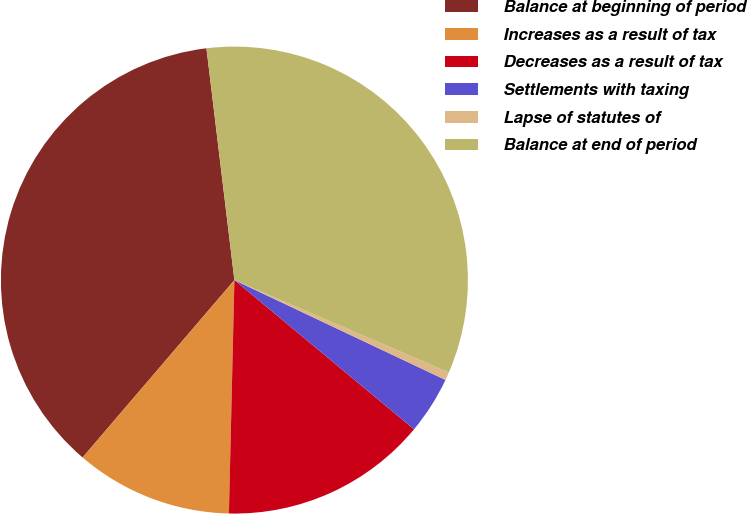Convert chart. <chart><loc_0><loc_0><loc_500><loc_500><pie_chart><fcel>Balance at beginning of period<fcel>Increases as a result of tax<fcel>Decreases as a result of tax<fcel>Settlements with taxing<fcel>Lapse of statutes of<fcel>Balance at end of period<nl><fcel>36.82%<fcel>10.89%<fcel>14.34%<fcel>4.0%<fcel>0.56%<fcel>33.38%<nl></chart> 